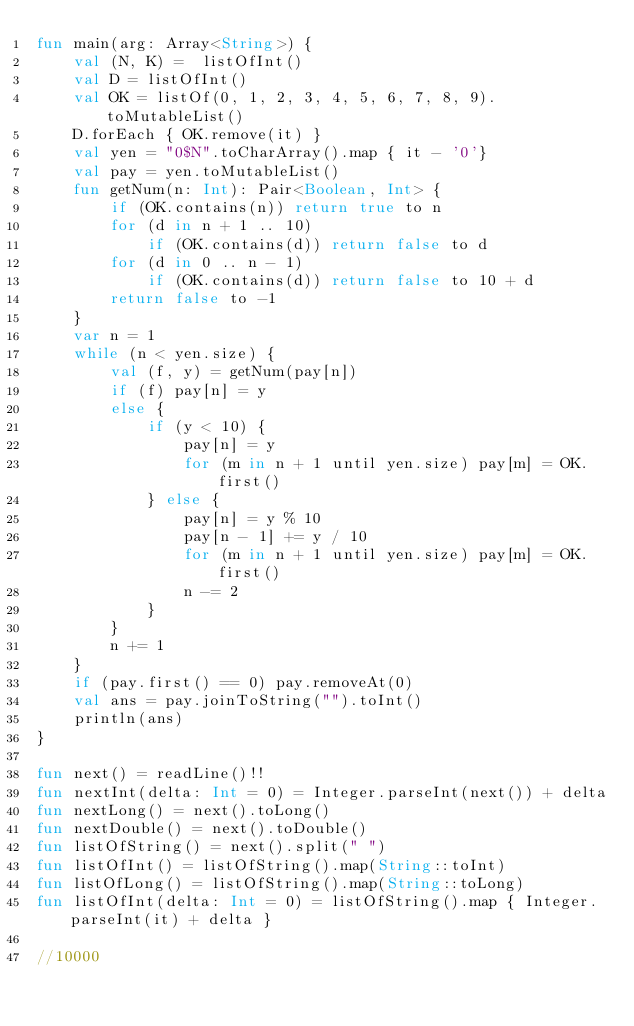<code> <loc_0><loc_0><loc_500><loc_500><_Kotlin_>fun main(arg: Array<String>) {
    val (N, K) =  listOfInt()
    val D = listOfInt()
    val OK = listOf(0, 1, 2, 3, 4, 5, 6, 7, 8, 9).toMutableList()
    D.forEach { OK.remove(it) }
    val yen = "0$N".toCharArray().map { it - '0'}
    val pay = yen.toMutableList()
    fun getNum(n: Int): Pair<Boolean, Int> {
        if (OK.contains(n)) return true to n
        for (d in n + 1 .. 10)
            if (OK.contains(d)) return false to d
        for (d in 0 .. n - 1)
            if (OK.contains(d)) return false to 10 + d
        return false to -1
    }
    var n = 1
    while (n < yen.size) {
        val (f, y) = getNum(pay[n])
        if (f) pay[n] = y
        else {
            if (y < 10) {
                pay[n] = y
                for (m in n + 1 until yen.size) pay[m] = OK.first()
            } else {
                pay[n] = y % 10
                pay[n - 1] += y / 10
                for (m in n + 1 until yen.size) pay[m] = OK.first()
                n -= 2
            }
        }
        n += 1
    }
    if (pay.first() == 0) pay.removeAt(0)
    val ans = pay.joinToString("").toInt()
    println(ans)
}

fun next() = readLine()!!
fun nextInt(delta: Int = 0) = Integer.parseInt(next()) + delta
fun nextLong() = next().toLong()
fun nextDouble() = next().toDouble()
fun listOfString() = next().split(" ")
fun listOfInt() = listOfString().map(String::toInt)
fun listOfLong() = listOfString().map(String::toLong)
fun listOfInt(delta: Int = 0) = listOfString().map { Integer.parseInt(it) + delta }

//10000
</code> 